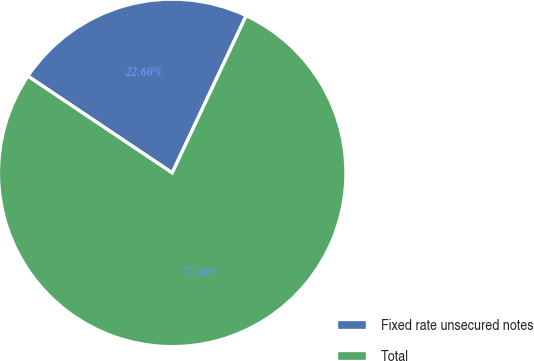<chart> <loc_0><loc_0><loc_500><loc_500><pie_chart><fcel>Fixed rate unsecured notes<fcel>Total<nl><fcel>22.6%<fcel>77.4%<nl></chart> 